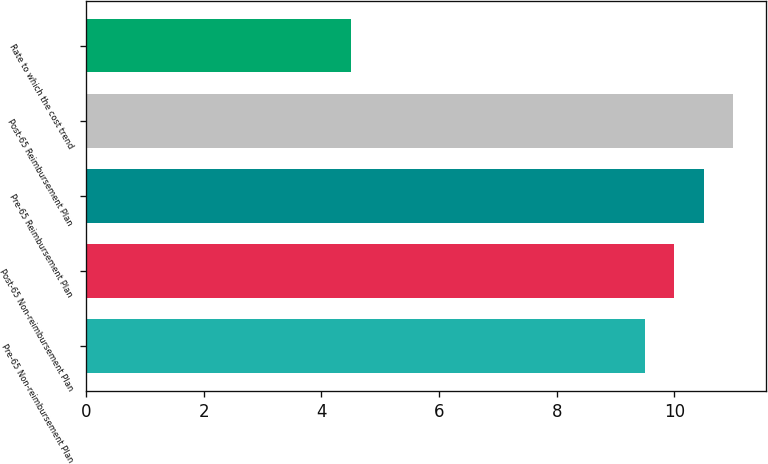Convert chart to OTSL. <chart><loc_0><loc_0><loc_500><loc_500><bar_chart><fcel>Pre-65 Non-reimbursement Plan<fcel>Post-65 Non-reimbursement Plan<fcel>Pre-65 Reimbursement Plan<fcel>Post-65 Reimbursement Plan<fcel>Rate to which the cost trend<nl><fcel>9.5<fcel>10<fcel>10.5<fcel>11<fcel>4.5<nl></chart> 